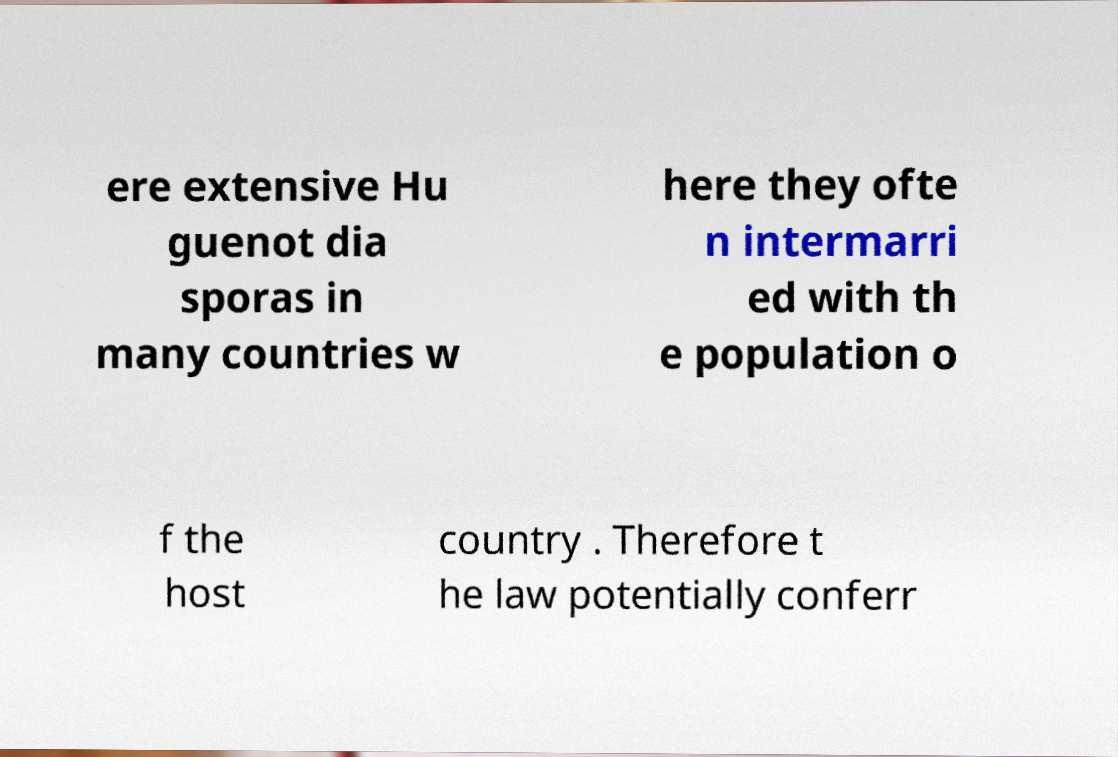Please identify and transcribe the text found in this image. ere extensive Hu guenot dia sporas in many countries w here they ofte n intermarri ed with th e population o f the host country . Therefore t he law potentially conferr 